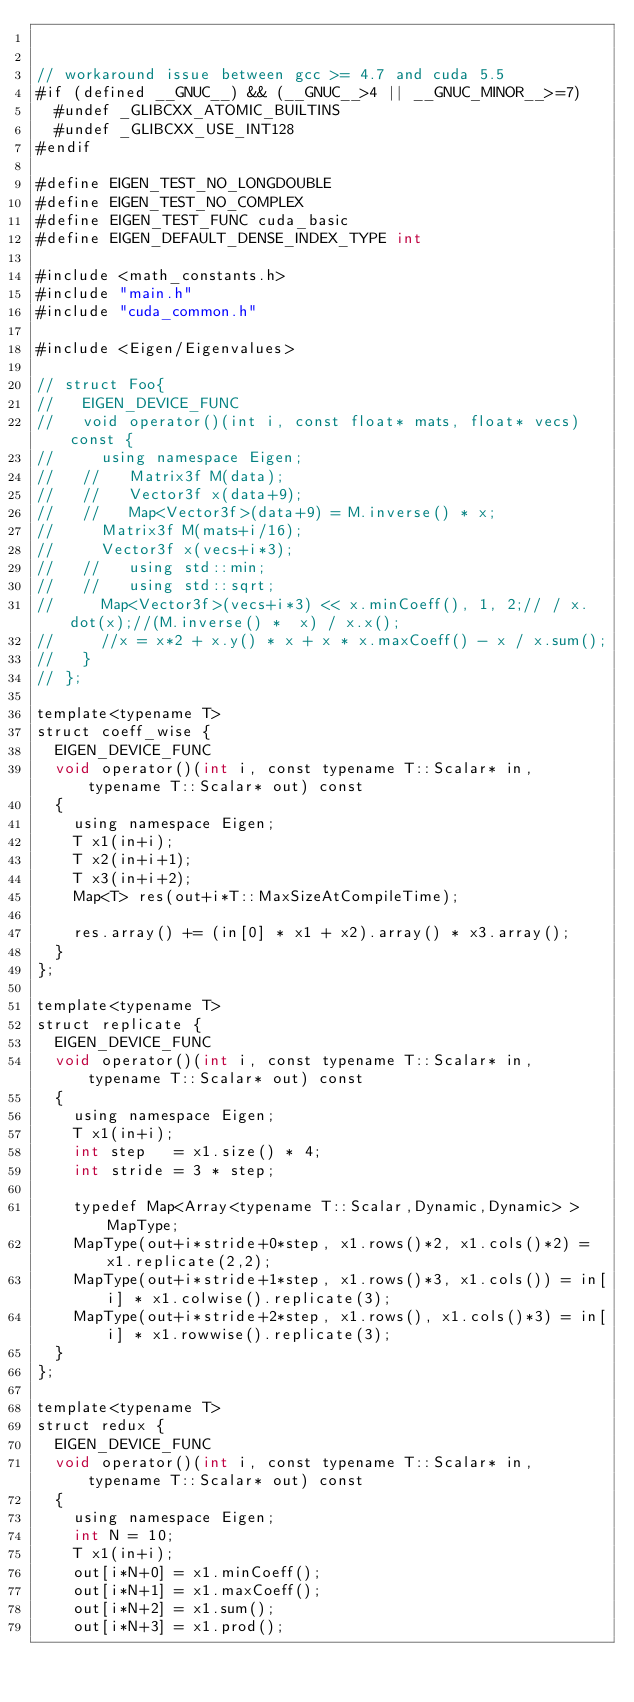<code> <loc_0><loc_0><loc_500><loc_500><_Cuda_>

// workaround issue between gcc >= 4.7 and cuda 5.5
#if (defined __GNUC__) && (__GNUC__>4 || __GNUC_MINOR__>=7)
  #undef _GLIBCXX_ATOMIC_BUILTINS
  #undef _GLIBCXX_USE_INT128
#endif

#define EIGEN_TEST_NO_LONGDOUBLE
#define EIGEN_TEST_NO_COMPLEX
#define EIGEN_TEST_FUNC cuda_basic
#define EIGEN_DEFAULT_DENSE_INDEX_TYPE int

#include <math_constants.h>
#include "main.h"
#include "cuda_common.h"

#include <Eigen/Eigenvalues>

// struct Foo{
//   EIGEN_DEVICE_FUNC
//   void operator()(int i, const float* mats, float* vecs) const {
//     using namespace Eigen;
//   //   Matrix3f M(data);
//   //   Vector3f x(data+9);
//   //   Map<Vector3f>(data+9) = M.inverse() * x;
//     Matrix3f M(mats+i/16);
//     Vector3f x(vecs+i*3);
//   //   using std::min;
//   //   using std::sqrt;
//     Map<Vector3f>(vecs+i*3) << x.minCoeff(), 1, 2;// / x.dot(x);//(M.inverse() *  x) / x.x();
//     //x = x*2 + x.y() * x + x * x.maxCoeff() - x / x.sum();
//   }
// };

template<typename T>
struct coeff_wise {
  EIGEN_DEVICE_FUNC
  void operator()(int i, const typename T::Scalar* in, typename T::Scalar* out) const
  {
    using namespace Eigen;
    T x1(in+i);
    T x2(in+i+1);
    T x3(in+i+2);
    Map<T> res(out+i*T::MaxSizeAtCompileTime);
    
    res.array() += (in[0] * x1 + x2).array() * x3.array();
  }
};

template<typename T>
struct replicate {
  EIGEN_DEVICE_FUNC
  void operator()(int i, const typename T::Scalar* in, typename T::Scalar* out) const
  {
    using namespace Eigen;
    T x1(in+i);
    int step   = x1.size() * 4;
    int stride = 3 * step;
    
    typedef Map<Array<typename T::Scalar,Dynamic,Dynamic> > MapType;
    MapType(out+i*stride+0*step, x1.rows()*2, x1.cols()*2) = x1.replicate(2,2);
    MapType(out+i*stride+1*step, x1.rows()*3, x1.cols()) = in[i] * x1.colwise().replicate(3);
    MapType(out+i*stride+2*step, x1.rows(), x1.cols()*3) = in[i] * x1.rowwise().replicate(3);
  }
};

template<typename T>
struct redux {
  EIGEN_DEVICE_FUNC
  void operator()(int i, const typename T::Scalar* in, typename T::Scalar* out) const
  {
    using namespace Eigen;
    int N = 10;
    T x1(in+i);
    out[i*N+0] = x1.minCoeff();
    out[i*N+1] = x1.maxCoeff();
    out[i*N+2] = x1.sum();
    out[i*N+3] = x1.prod();</code> 